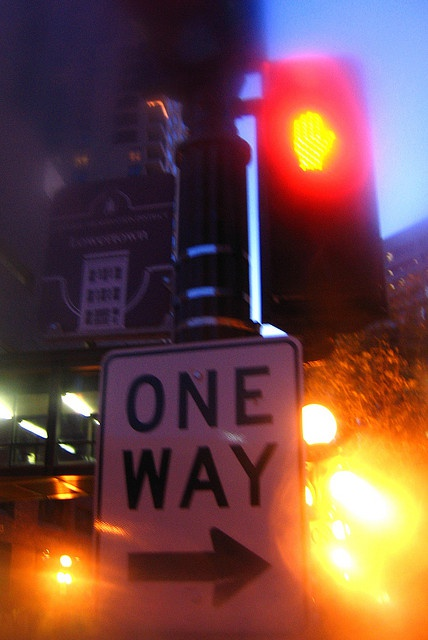Describe the objects in this image and their specific colors. I can see a traffic light in navy, black, maroon, salmon, and red tones in this image. 